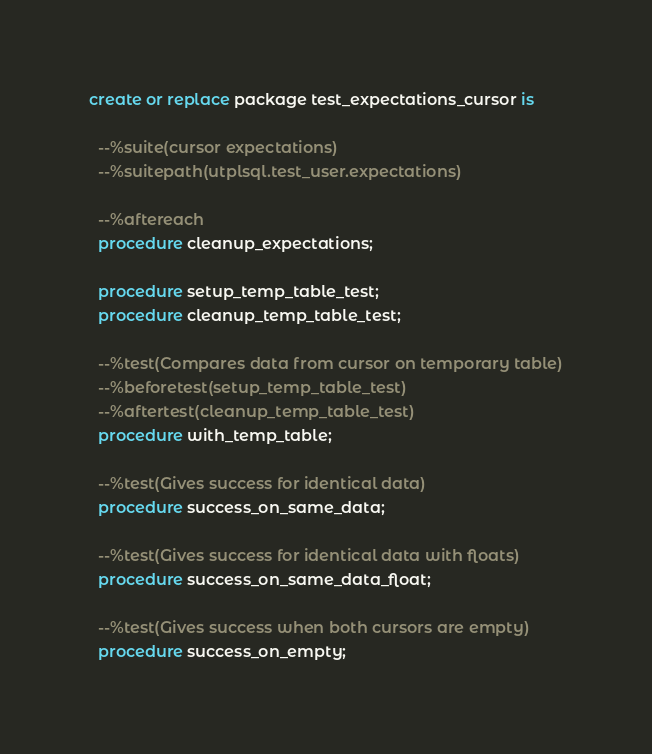Convert code to text. <code><loc_0><loc_0><loc_500><loc_500><_SQL_>create or replace package test_expectations_cursor is

  --%suite(cursor expectations)
  --%suitepath(utplsql.test_user.expectations)

  --%aftereach
  procedure cleanup_expectations;

  procedure setup_temp_table_test;
  procedure cleanup_temp_table_test;

  --%test(Compares data from cursor on temporary table)
  --%beforetest(setup_temp_table_test)
  --%aftertest(cleanup_temp_table_test)
  procedure with_temp_table;

  --%test(Gives success for identical data)
  procedure success_on_same_data;

  --%test(Gives success for identical data with floats)
  procedure success_on_same_data_float;

  --%test(Gives success when both cursors are empty)
  procedure success_on_empty;
</code> 